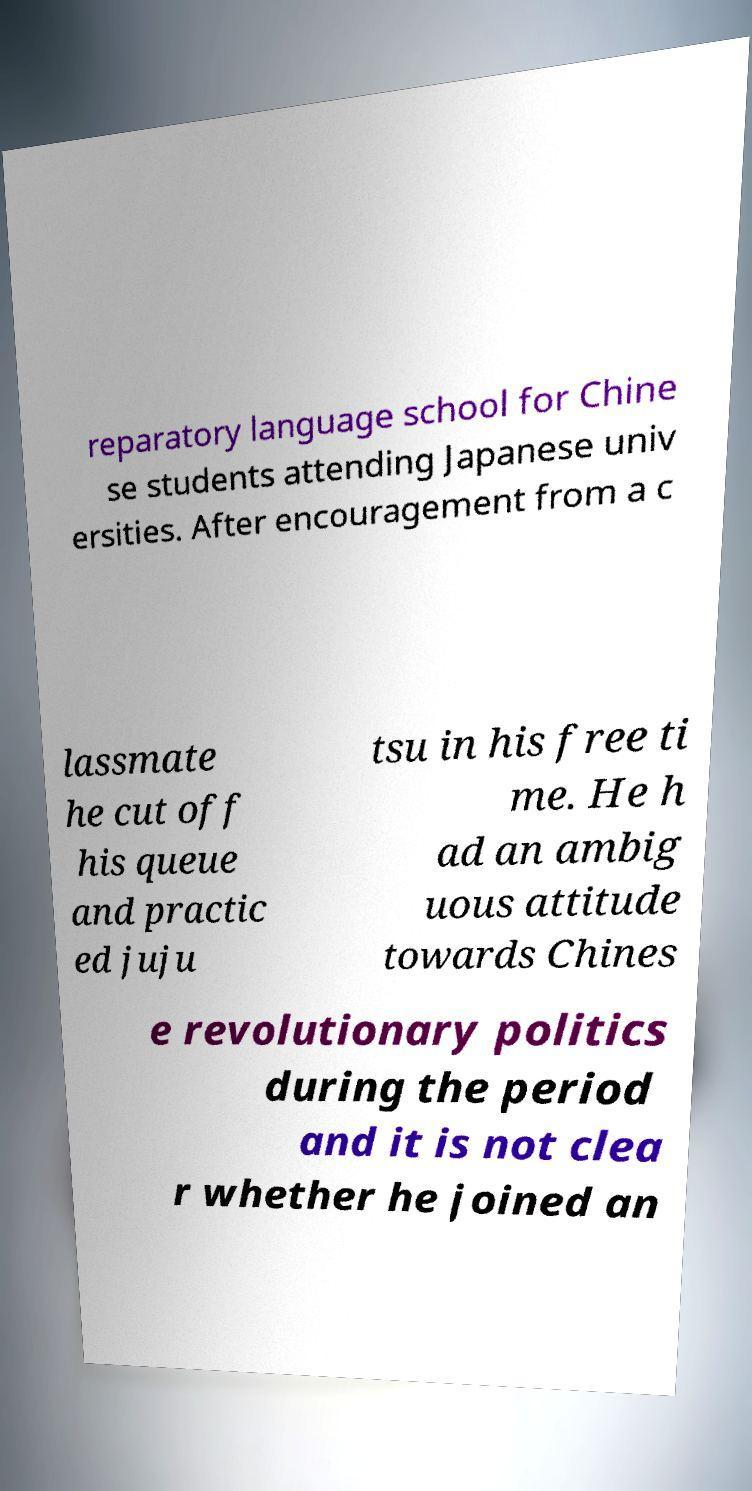Could you assist in decoding the text presented in this image and type it out clearly? reparatory language school for Chine se students attending Japanese univ ersities. After encouragement from a c lassmate he cut off his queue and practic ed juju tsu in his free ti me. He h ad an ambig uous attitude towards Chines e revolutionary politics during the period and it is not clea r whether he joined an 